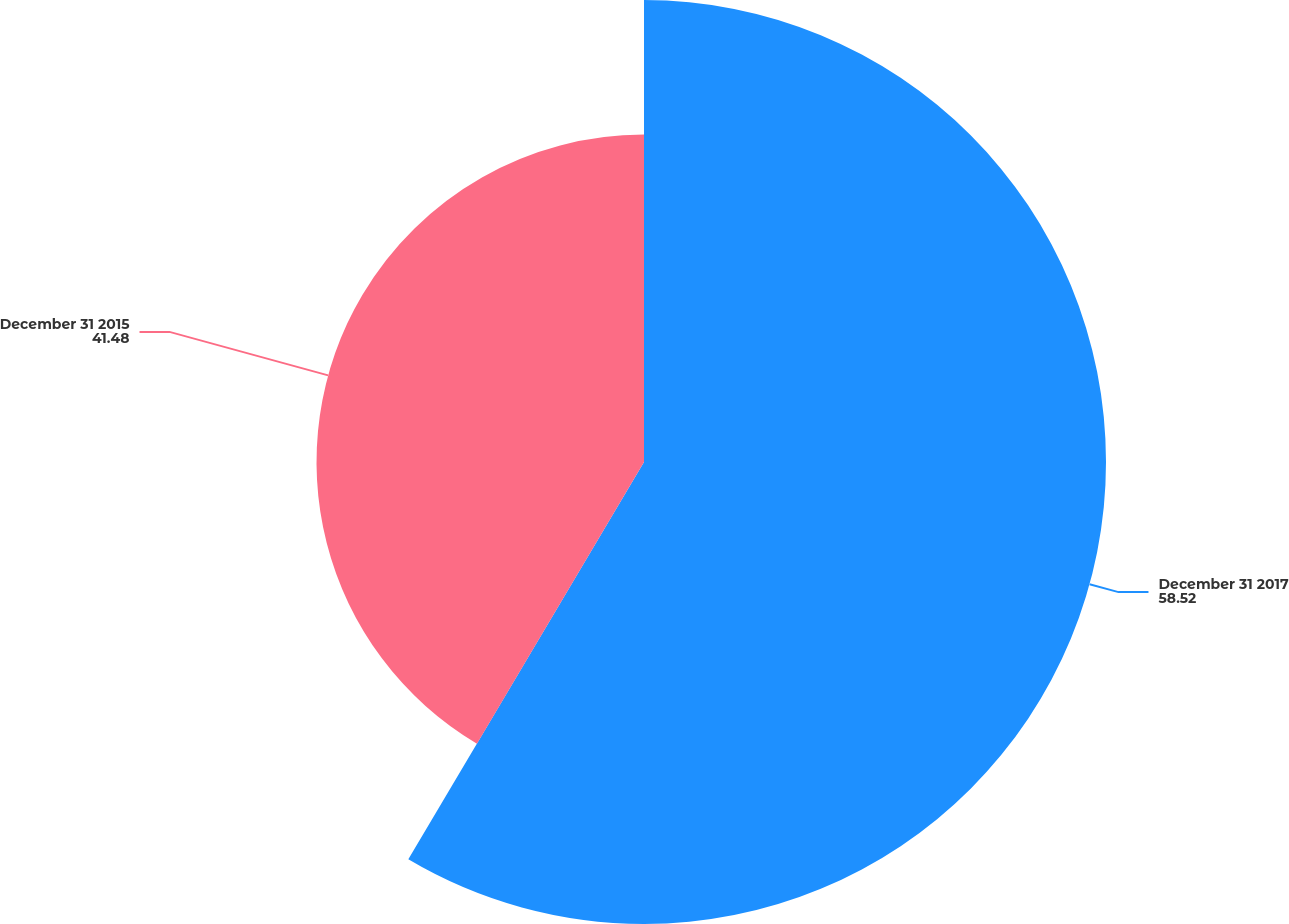Convert chart to OTSL. <chart><loc_0><loc_0><loc_500><loc_500><pie_chart><fcel>December 31 2017<fcel>December 31 2015<nl><fcel>58.52%<fcel>41.48%<nl></chart> 